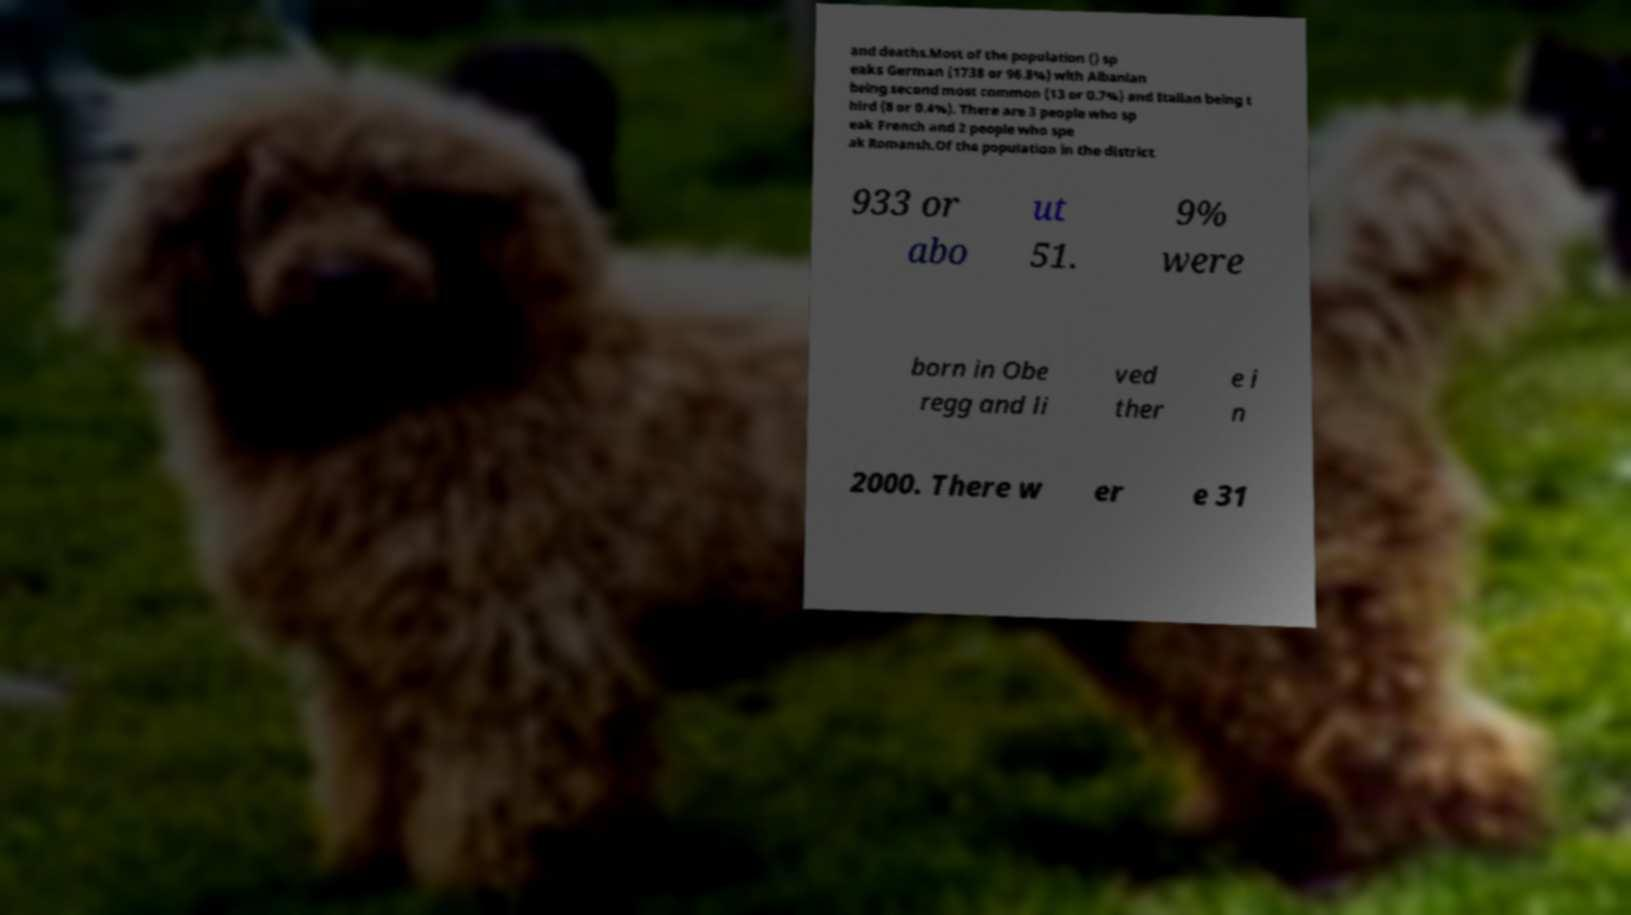What messages or text are displayed in this image? I need them in a readable, typed format. and deaths.Most of the population () sp eaks German (1738 or 96.8%) with Albanian being second most common (13 or 0.7%) and Italian being t hird (8 or 0.4%). There are 3 people who sp eak French and 2 people who spe ak Romansh.Of the population in the district 933 or abo ut 51. 9% were born in Obe regg and li ved ther e i n 2000. There w er e 31 